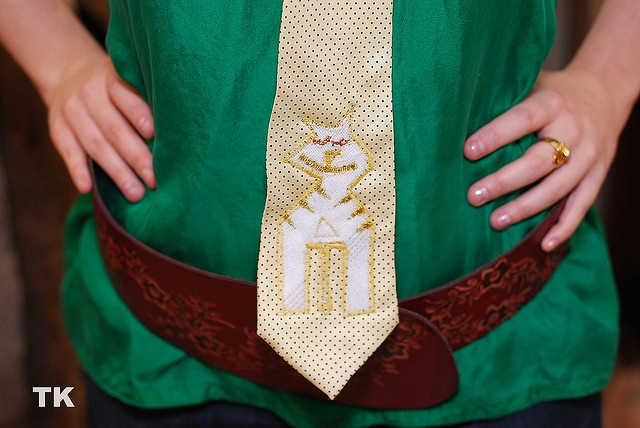Describe the objects in this image and their specific colors. I can see people in teal, salmon, black, darkgreen, and lightpink tones and tie in salmon, lightgray, and tan tones in this image. 